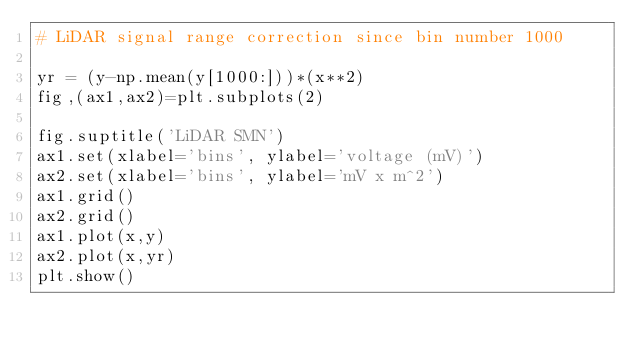<code> <loc_0><loc_0><loc_500><loc_500><_Python_># LiDAR signal range correction since bin number 1000

yr = (y-np.mean(y[1000:]))*(x**2)
fig,(ax1,ax2)=plt.subplots(2)

fig.suptitle('LiDAR SMN')
ax1.set(xlabel='bins', ylabel='voltage (mV)')
ax2.set(xlabel='bins', ylabel='mV x m^2')
ax1.grid()
ax2.grid()
ax1.plot(x,y)
ax2.plot(x,yr)
plt.show()
</code> 